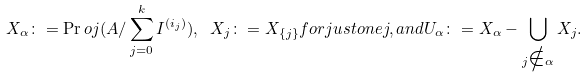<formula> <loc_0><loc_0><loc_500><loc_500>X _ { \alpha } \colon = \Pr o j ( A / \sum _ { j = 0 } ^ { k } I ^ { ( i _ { j } ) } ) , \ X _ { j } \colon = X _ { \{ j \} } f o r j u s t o n e j , a n d U _ { \alpha } \colon = X _ { \alpha } - \bigcup _ { j \notin \alpha } X _ { j } .</formula> 